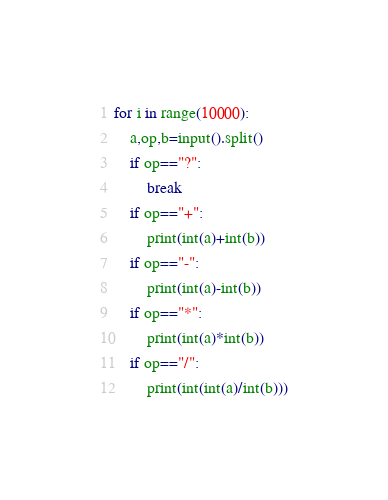Convert code to text. <code><loc_0><loc_0><loc_500><loc_500><_Python_>
for i in range(10000):
    a,op,b=input().split()
    if op=="?":
        break
    if op=="+":
        print(int(a)+int(b))
    if op=="-":
        print(int(a)-int(b))
    if op=="*":
        print(int(a)*int(b))
    if op=="/":
        print(int(int(a)/int(b)))
</code> 